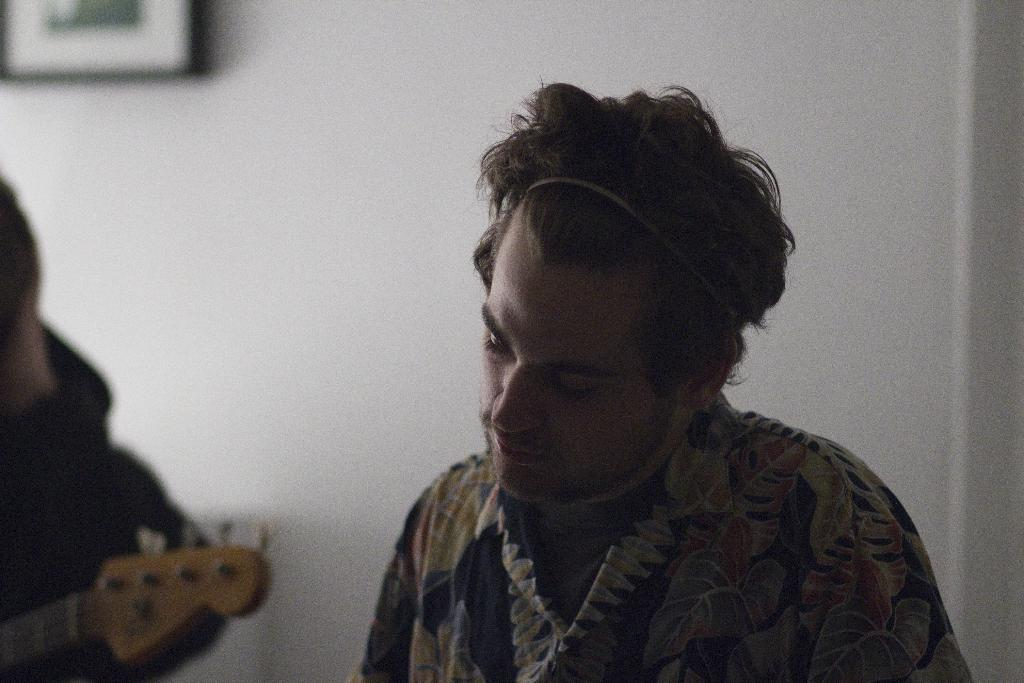What is the main subject of the image? There is a man in the image. What is the man holding in the image? There is a person holding a guitar in the image. What type of hair is visible on the guitar in the image? There is no hair visible on the guitar in the image, as guitars do not have hair. 